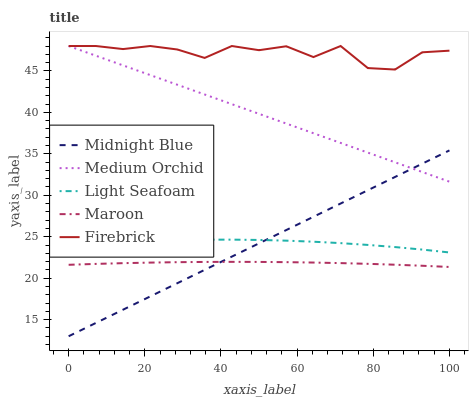Does Maroon have the minimum area under the curve?
Answer yes or no. Yes. Does Firebrick have the maximum area under the curve?
Answer yes or no. Yes. Does Medium Orchid have the minimum area under the curve?
Answer yes or no. No. Does Medium Orchid have the maximum area under the curve?
Answer yes or no. No. Is Midnight Blue the smoothest?
Answer yes or no. Yes. Is Firebrick the roughest?
Answer yes or no. Yes. Is Medium Orchid the smoothest?
Answer yes or no. No. Is Medium Orchid the roughest?
Answer yes or no. No. Does Midnight Blue have the lowest value?
Answer yes or no. Yes. Does Medium Orchid have the lowest value?
Answer yes or no. No. Does Medium Orchid have the highest value?
Answer yes or no. Yes. Does Midnight Blue have the highest value?
Answer yes or no. No. Is Light Seafoam less than Medium Orchid?
Answer yes or no. Yes. Is Medium Orchid greater than Maroon?
Answer yes or no. Yes. Does Medium Orchid intersect Firebrick?
Answer yes or no. Yes. Is Medium Orchid less than Firebrick?
Answer yes or no. No. Is Medium Orchid greater than Firebrick?
Answer yes or no. No. Does Light Seafoam intersect Medium Orchid?
Answer yes or no. No. 